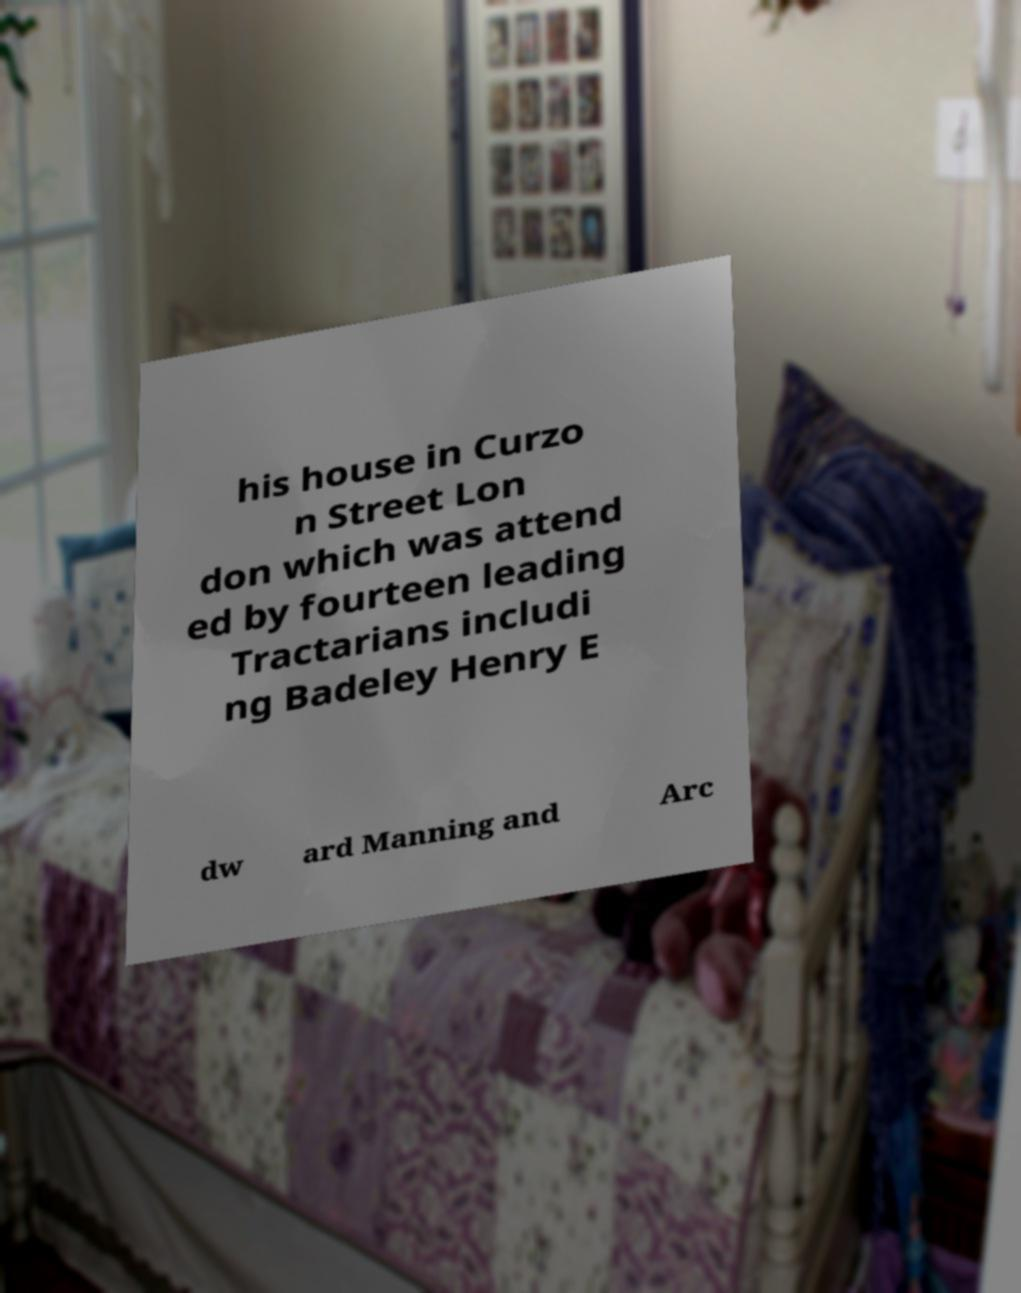There's text embedded in this image that I need extracted. Can you transcribe it verbatim? his house in Curzo n Street Lon don which was attend ed by fourteen leading Tractarians includi ng Badeley Henry E dw ard Manning and Arc 